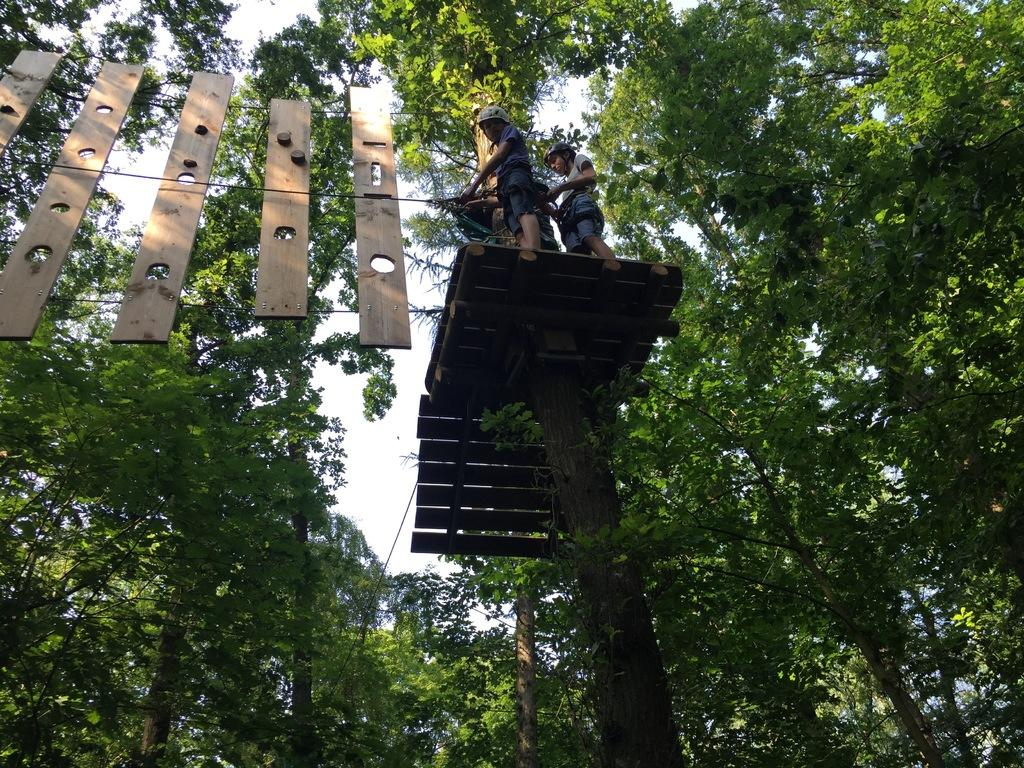What type of vegetation is present in the image? There are trees in the image. How many people can be seen in the image? There are two people standing in the image. What is visible at the top of the image? The sky is visible at the top of the image. What type of wool is being used to provide comfort in the image? There is no wool or reference to comfort in the image; it features trees and two people standing. What part of the image is made of wool? There is no part of the image made of wool, as the image consists of trees, people, and the sky. 